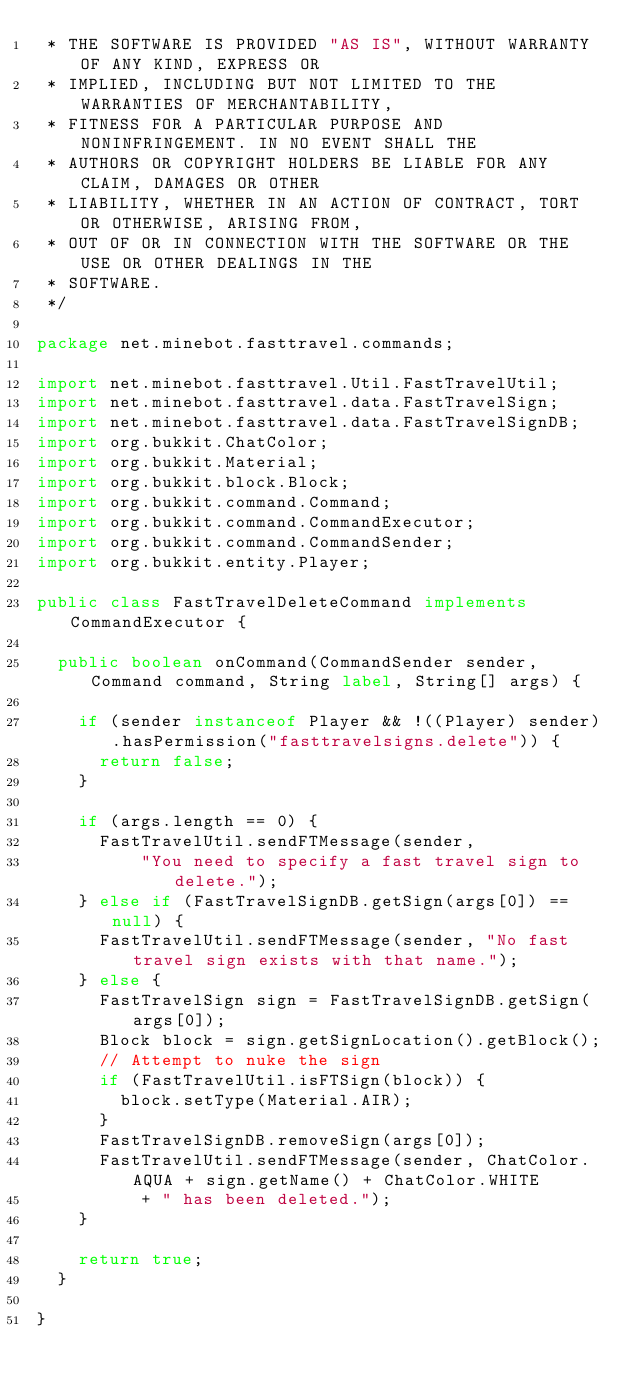Convert code to text. <code><loc_0><loc_0><loc_500><loc_500><_Java_> * THE SOFTWARE IS PROVIDED "AS IS", WITHOUT WARRANTY OF ANY KIND, EXPRESS OR
 * IMPLIED, INCLUDING BUT NOT LIMITED TO THE WARRANTIES OF MERCHANTABILITY,
 * FITNESS FOR A PARTICULAR PURPOSE AND NONINFRINGEMENT. IN NO EVENT SHALL THE
 * AUTHORS OR COPYRIGHT HOLDERS BE LIABLE FOR ANY CLAIM, DAMAGES OR OTHER
 * LIABILITY, WHETHER IN AN ACTION OF CONTRACT, TORT OR OTHERWISE, ARISING FROM,
 * OUT OF OR IN CONNECTION WITH THE SOFTWARE OR THE USE OR OTHER DEALINGS IN THE
 * SOFTWARE.
 */

package net.minebot.fasttravel.commands;

import net.minebot.fasttravel.Util.FastTravelUtil;
import net.minebot.fasttravel.data.FastTravelSign;
import net.minebot.fasttravel.data.FastTravelSignDB;
import org.bukkit.ChatColor;
import org.bukkit.Material;
import org.bukkit.block.Block;
import org.bukkit.command.Command;
import org.bukkit.command.CommandExecutor;
import org.bukkit.command.CommandSender;
import org.bukkit.entity.Player;

public class FastTravelDeleteCommand implements CommandExecutor {

	public boolean onCommand(CommandSender sender, Command command, String label, String[] args) {

		if (sender instanceof Player && !((Player) sender).hasPermission("fasttravelsigns.delete")) {
			return false;
		}

		if (args.length == 0) {
			FastTravelUtil.sendFTMessage(sender,
					"You need to specify a fast travel sign to delete.");
		} else if (FastTravelSignDB.getSign(args[0]) == null) {
			FastTravelUtil.sendFTMessage(sender, "No fast travel sign exists with that name.");
		} else {
			FastTravelSign sign = FastTravelSignDB.getSign(args[0]);
			Block block = sign.getSignLocation().getBlock();
			// Attempt to nuke the sign
			if (FastTravelUtil.isFTSign(block)) {
				block.setType(Material.AIR);
			}
			FastTravelSignDB.removeSign(args[0]);
			FastTravelUtil.sendFTMessage(sender, ChatColor.AQUA + sign.getName() + ChatColor.WHITE
					+ " has been deleted.");
		}

		return true;
	}

}
</code> 